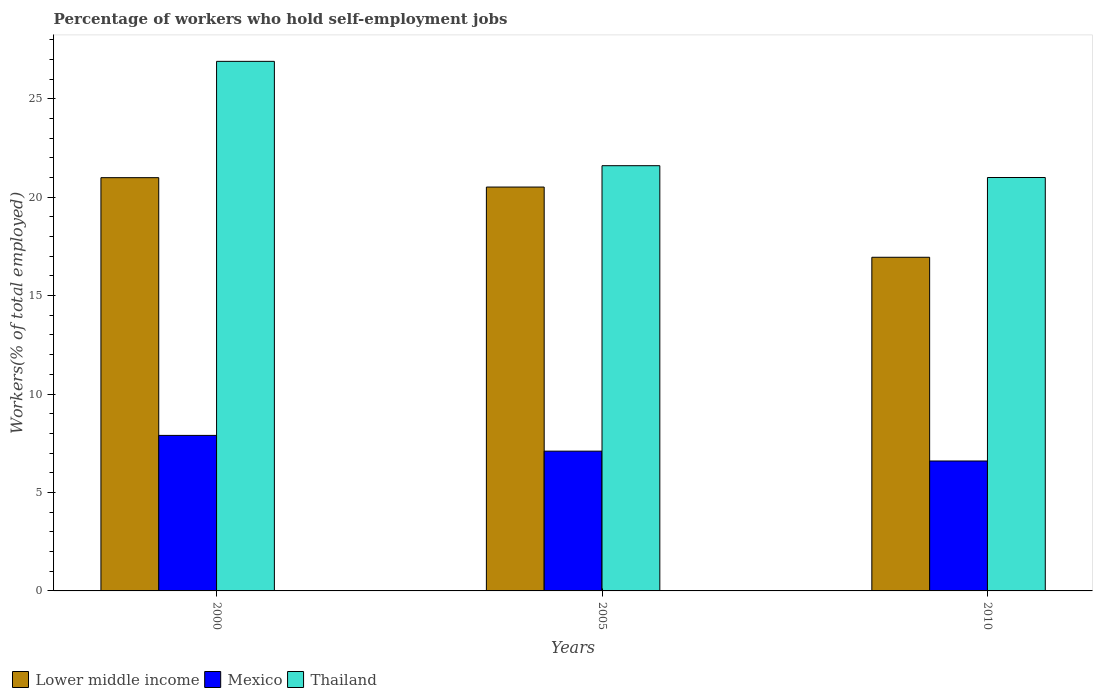How many different coloured bars are there?
Offer a terse response. 3. What is the label of the 3rd group of bars from the left?
Your response must be concise. 2010. What is the percentage of self-employed workers in Lower middle income in 2010?
Offer a very short reply. 16.95. Across all years, what is the maximum percentage of self-employed workers in Mexico?
Give a very brief answer. 7.9. Across all years, what is the minimum percentage of self-employed workers in Lower middle income?
Give a very brief answer. 16.95. What is the total percentage of self-employed workers in Thailand in the graph?
Offer a terse response. 69.5. What is the difference between the percentage of self-employed workers in Mexico in 2000 and that in 2005?
Ensure brevity in your answer.  0.8. What is the difference between the percentage of self-employed workers in Lower middle income in 2000 and the percentage of self-employed workers in Mexico in 2005?
Give a very brief answer. 13.89. What is the average percentage of self-employed workers in Thailand per year?
Make the answer very short. 23.17. In the year 2005, what is the difference between the percentage of self-employed workers in Lower middle income and percentage of self-employed workers in Mexico?
Your response must be concise. 13.41. What is the ratio of the percentage of self-employed workers in Thailand in 2000 to that in 2010?
Offer a terse response. 1.28. Is the difference between the percentage of self-employed workers in Lower middle income in 2000 and 2005 greater than the difference between the percentage of self-employed workers in Mexico in 2000 and 2005?
Keep it short and to the point. No. What is the difference between the highest and the second highest percentage of self-employed workers in Thailand?
Your response must be concise. 5.3. What is the difference between the highest and the lowest percentage of self-employed workers in Mexico?
Offer a terse response. 1.3. In how many years, is the percentage of self-employed workers in Lower middle income greater than the average percentage of self-employed workers in Lower middle income taken over all years?
Offer a terse response. 2. Is the sum of the percentage of self-employed workers in Mexico in 2000 and 2010 greater than the maximum percentage of self-employed workers in Lower middle income across all years?
Your response must be concise. No. What does the 3rd bar from the left in 2010 represents?
Your answer should be compact. Thailand. Is it the case that in every year, the sum of the percentage of self-employed workers in Thailand and percentage of self-employed workers in Mexico is greater than the percentage of self-employed workers in Lower middle income?
Offer a very short reply. Yes. How many bars are there?
Ensure brevity in your answer.  9. How many years are there in the graph?
Your response must be concise. 3. What is the difference between two consecutive major ticks on the Y-axis?
Ensure brevity in your answer.  5. Are the values on the major ticks of Y-axis written in scientific E-notation?
Ensure brevity in your answer.  No. Does the graph contain any zero values?
Your answer should be very brief. No. Where does the legend appear in the graph?
Your answer should be compact. Bottom left. How are the legend labels stacked?
Offer a terse response. Horizontal. What is the title of the graph?
Your response must be concise. Percentage of workers who hold self-employment jobs. What is the label or title of the Y-axis?
Provide a succinct answer. Workers(% of total employed). What is the Workers(% of total employed) of Lower middle income in 2000?
Keep it short and to the point. 20.99. What is the Workers(% of total employed) in Mexico in 2000?
Keep it short and to the point. 7.9. What is the Workers(% of total employed) of Thailand in 2000?
Your answer should be very brief. 26.9. What is the Workers(% of total employed) in Lower middle income in 2005?
Offer a very short reply. 20.51. What is the Workers(% of total employed) of Mexico in 2005?
Offer a very short reply. 7.1. What is the Workers(% of total employed) in Thailand in 2005?
Offer a terse response. 21.6. What is the Workers(% of total employed) of Lower middle income in 2010?
Ensure brevity in your answer.  16.95. What is the Workers(% of total employed) of Mexico in 2010?
Give a very brief answer. 6.6. Across all years, what is the maximum Workers(% of total employed) of Lower middle income?
Provide a succinct answer. 20.99. Across all years, what is the maximum Workers(% of total employed) in Mexico?
Offer a very short reply. 7.9. Across all years, what is the maximum Workers(% of total employed) of Thailand?
Offer a terse response. 26.9. Across all years, what is the minimum Workers(% of total employed) in Lower middle income?
Provide a short and direct response. 16.95. Across all years, what is the minimum Workers(% of total employed) of Mexico?
Your response must be concise. 6.6. What is the total Workers(% of total employed) in Lower middle income in the graph?
Your answer should be very brief. 58.45. What is the total Workers(% of total employed) in Mexico in the graph?
Offer a very short reply. 21.6. What is the total Workers(% of total employed) in Thailand in the graph?
Provide a succinct answer. 69.5. What is the difference between the Workers(% of total employed) of Lower middle income in 2000 and that in 2005?
Provide a succinct answer. 0.48. What is the difference between the Workers(% of total employed) in Lower middle income in 2000 and that in 2010?
Your answer should be very brief. 4.04. What is the difference between the Workers(% of total employed) in Mexico in 2000 and that in 2010?
Offer a very short reply. 1.3. What is the difference between the Workers(% of total employed) of Lower middle income in 2005 and that in 2010?
Offer a very short reply. 3.57. What is the difference between the Workers(% of total employed) in Mexico in 2005 and that in 2010?
Your answer should be very brief. 0.5. What is the difference between the Workers(% of total employed) in Lower middle income in 2000 and the Workers(% of total employed) in Mexico in 2005?
Provide a short and direct response. 13.89. What is the difference between the Workers(% of total employed) of Lower middle income in 2000 and the Workers(% of total employed) of Thailand in 2005?
Your response must be concise. -0.61. What is the difference between the Workers(% of total employed) in Mexico in 2000 and the Workers(% of total employed) in Thailand in 2005?
Your answer should be compact. -13.7. What is the difference between the Workers(% of total employed) of Lower middle income in 2000 and the Workers(% of total employed) of Mexico in 2010?
Provide a short and direct response. 14.39. What is the difference between the Workers(% of total employed) in Lower middle income in 2000 and the Workers(% of total employed) in Thailand in 2010?
Make the answer very short. -0.01. What is the difference between the Workers(% of total employed) in Lower middle income in 2005 and the Workers(% of total employed) in Mexico in 2010?
Give a very brief answer. 13.91. What is the difference between the Workers(% of total employed) in Lower middle income in 2005 and the Workers(% of total employed) in Thailand in 2010?
Your answer should be very brief. -0.49. What is the difference between the Workers(% of total employed) of Mexico in 2005 and the Workers(% of total employed) of Thailand in 2010?
Offer a terse response. -13.9. What is the average Workers(% of total employed) in Lower middle income per year?
Give a very brief answer. 19.48. What is the average Workers(% of total employed) of Thailand per year?
Your answer should be compact. 23.17. In the year 2000, what is the difference between the Workers(% of total employed) of Lower middle income and Workers(% of total employed) of Mexico?
Your answer should be compact. 13.09. In the year 2000, what is the difference between the Workers(% of total employed) in Lower middle income and Workers(% of total employed) in Thailand?
Give a very brief answer. -5.91. In the year 2005, what is the difference between the Workers(% of total employed) in Lower middle income and Workers(% of total employed) in Mexico?
Give a very brief answer. 13.41. In the year 2005, what is the difference between the Workers(% of total employed) in Lower middle income and Workers(% of total employed) in Thailand?
Make the answer very short. -1.09. In the year 2010, what is the difference between the Workers(% of total employed) in Lower middle income and Workers(% of total employed) in Mexico?
Ensure brevity in your answer.  10.35. In the year 2010, what is the difference between the Workers(% of total employed) of Lower middle income and Workers(% of total employed) of Thailand?
Give a very brief answer. -4.05. In the year 2010, what is the difference between the Workers(% of total employed) of Mexico and Workers(% of total employed) of Thailand?
Offer a very short reply. -14.4. What is the ratio of the Workers(% of total employed) in Lower middle income in 2000 to that in 2005?
Provide a short and direct response. 1.02. What is the ratio of the Workers(% of total employed) of Mexico in 2000 to that in 2005?
Keep it short and to the point. 1.11. What is the ratio of the Workers(% of total employed) of Thailand in 2000 to that in 2005?
Your answer should be very brief. 1.25. What is the ratio of the Workers(% of total employed) in Lower middle income in 2000 to that in 2010?
Your answer should be compact. 1.24. What is the ratio of the Workers(% of total employed) in Mexico in 2000 to that in 2010?
Provide a succinct answer. 1.2. What is the ratio of the Workers(% of total employed) of Thailand in 2000 to that in 2010?
Provide a succinct answer. 1.28. What is the ratio of the Workers(% of total employed) of Lower middle income in 2005 to that in 2010?
Make the answer very short. 1.21. What is the ratio of the Workers(% of total employed) of Mexico in 2005 to that in 2010?
Keep it short and to the point. 1.08. What is the ratio of the Workers(% of total employed) of Thailand in 2005 to that in 2010?
Ensure brevity in your answer.  1.03. What is the difference between the highest and the second highest Workers(% of total employed) in Lower middle income?
Your response must be concise. 0.48. What is the difference between the highest and the second highest Workers(% of total employed) in Mexico?
Keep it short and to the point. 0.8. What is the difference between the highest and the second highest Workers(% of total employed) of Thailand?
Offer a very short reply. 5.3. What is the difference between the highest and the lowest Workers(% of total employed) of Lower middle income?
Offer a terse response. 4.04. What is the difference between the highest and the lowest Workers(% of total employed) in Mexico?
Provide a succinct answer. 1.3. What is the difference between the highest and the lowest Workers(% of total employed) in Thailand?
Your answer should be very brief. 5.9. 